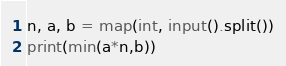<code> <loc_0><loc_0><loc_500><loc_500><_Python_>n, a, b = map(int, input().split())
print(min(a*n,b))</code> 